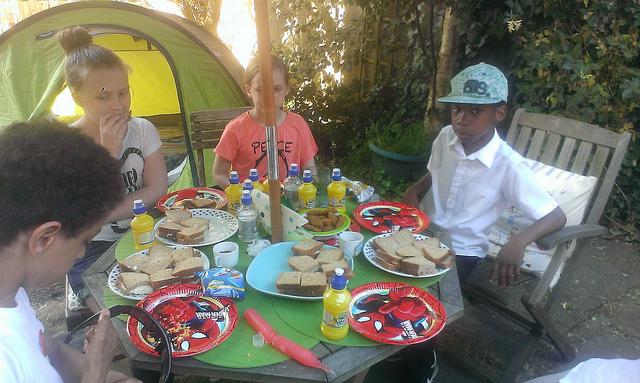What meal is the girl eating?
Quick response, please. Lunch. How many kids are sitting at the table?
Short answer required. 4. Are they having lunch?
Give a very brief answer. Yes. How many people are at the table?
Answer briefly. 4. Are the kids eating healthy food?
Be succinct. No. What superhero is shown on the paper plate?
Short answer required. Spiderman. 